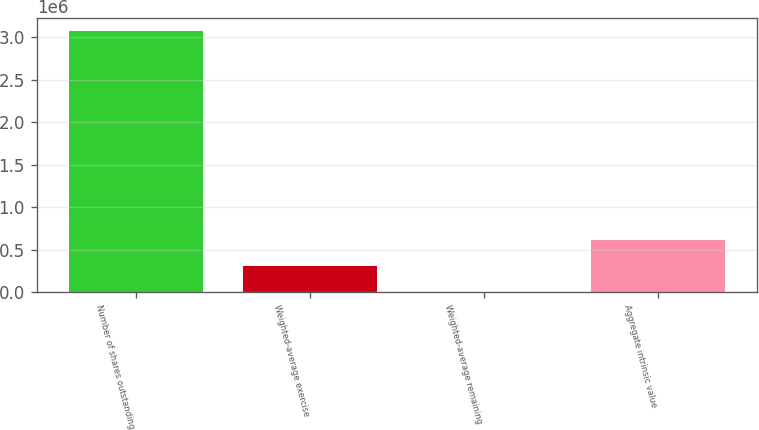Convert chart to OTSL. <chart><loc_0><loc_0><loc_500><loc_500><bar_chart><fcel>Number of shares outstanding<fcel>Weighted-average exercise<fcel>Weighted-average remaining<fcel>Aggregate intrinsic value<nl><fcel>3.07032e+06<fcel>307037<fcel>5.7<fcel>614069<nl></chart> 